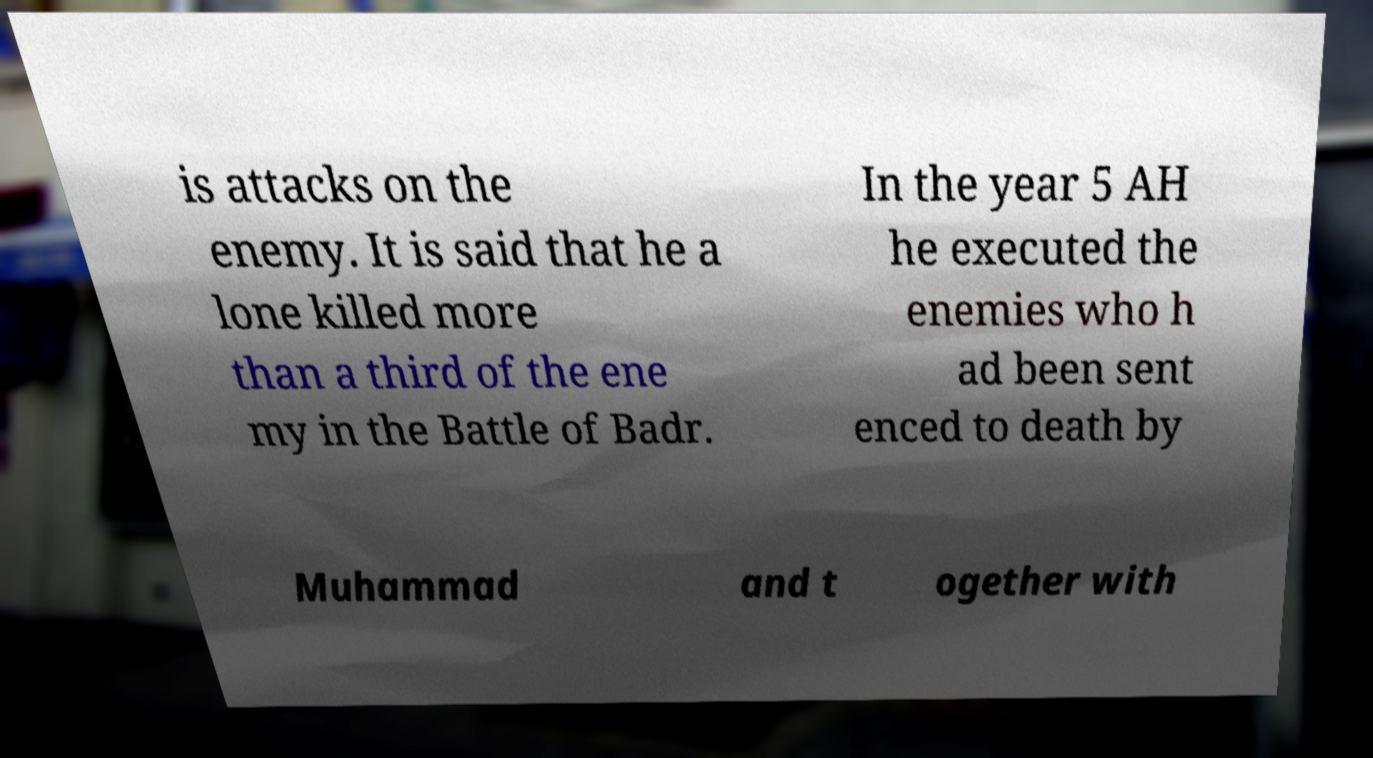For documentation purposes, I need the text within this image transcribed. Could you provide that? is attacks on the enemy. It is said that he a lone killed more than a third of the ene my in the Battle of Badr. In the year 5 AH he executed the enemies who h ad been sent enced to death by Muhammad and t ogether with 